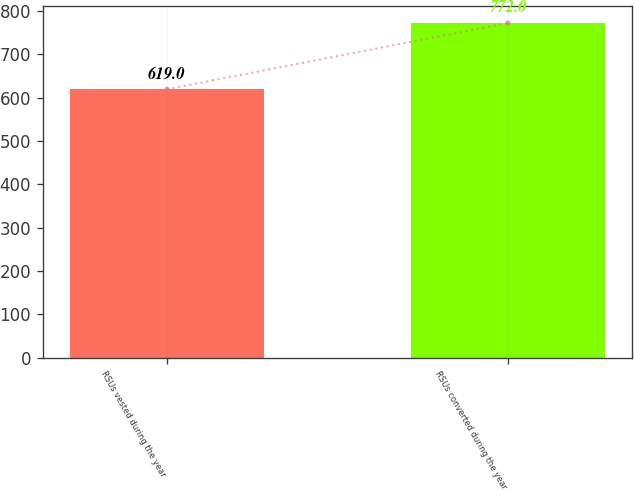Convert chart. <chart><loc_0><loc_0><loc_500><loc_500><bar_chart><fcel>RSUs vested during the year<fcel>RSUs converted during the year<nl><fcel>619<fcel>772<nl></chart> 